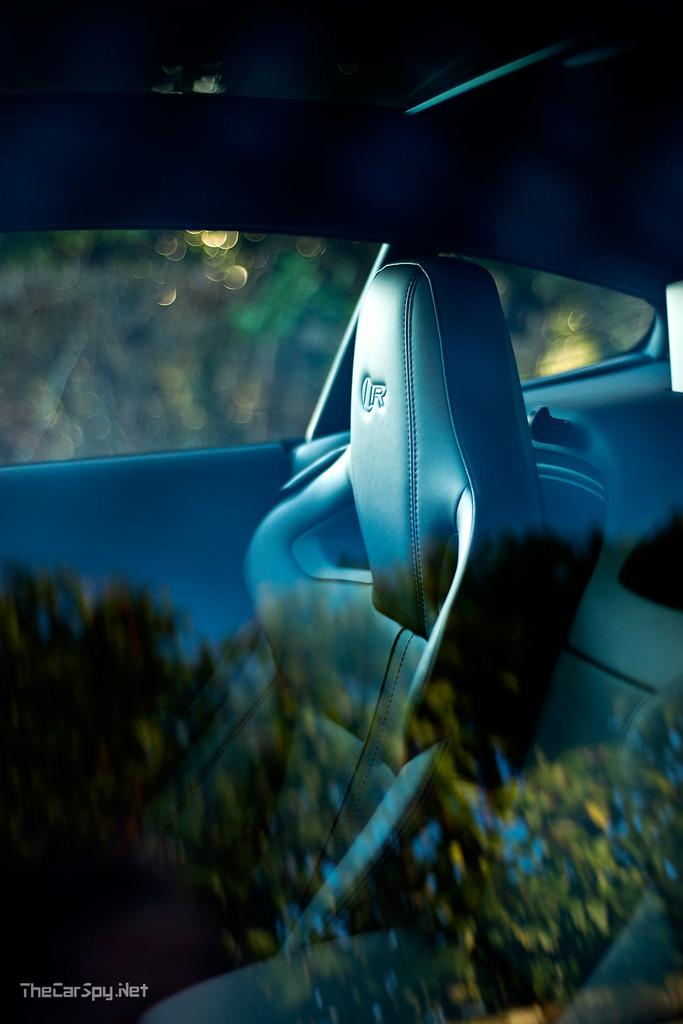What is the main subject of the image? There is a car in the image. Can you describe the background of the image? The background of the image is blurry. Where is the bun being used in the image? There is no bun present in the image. What type of battle is taking place in the image? There is no battle present in the image; it features a car and a blurry background. 